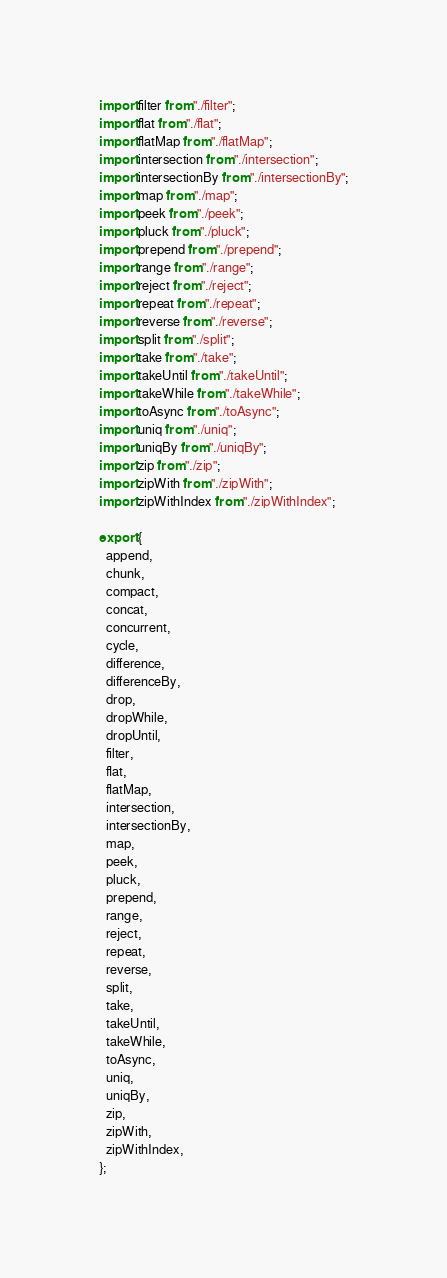Convert code to text. <code><loc_0><loc_0><loc_500><loc_500><_TypeScript_>import filter from "./filter";
import flat from "./flat";
import flatMap from "./flatMap";
import intersection from "./intersection";
import intersectionBy from "./intersectionBy";
import map from "./map";
import peek from "./peek";
import pluck from "./pluck";
import prepend from "./prepend";
import range from "./range";
import reject from "./reject";
import repeat from "./repeat";
import reverse from "./reverse";
import split from "./split";
import take from "./take";
import takeUntil from "./takeUntil";
import takeWhile from "./takeWhile";
import toAsync from "./toAsync";
import uniq from "./uniq";
import uniqBy from "./uniqBy";
import zip from "./zip";
import zipWith from "./zipWith";
import zipWithIndex from "./zipWithIndex";

export {
  append,
  chunk,
  compact,
  concat,
  concurrent,
  cycle,
  difference,
  differenceBy,
  drop,
  dropWhile,
  dropUntil,
  filter,
  flat,
  flatMap,
  intersection,
  intersectionBy,
  map,
  peek,
  pluck,
  prepend,
  range,
  reject,
  repeat,
  reverse,
  split,
  take,
  takeUntil,
  takeWhile,
  toAsync,
  uniq,
  uniqBy,
  zip,
  zipWith,
  zipWithIndex,
};
</code> 